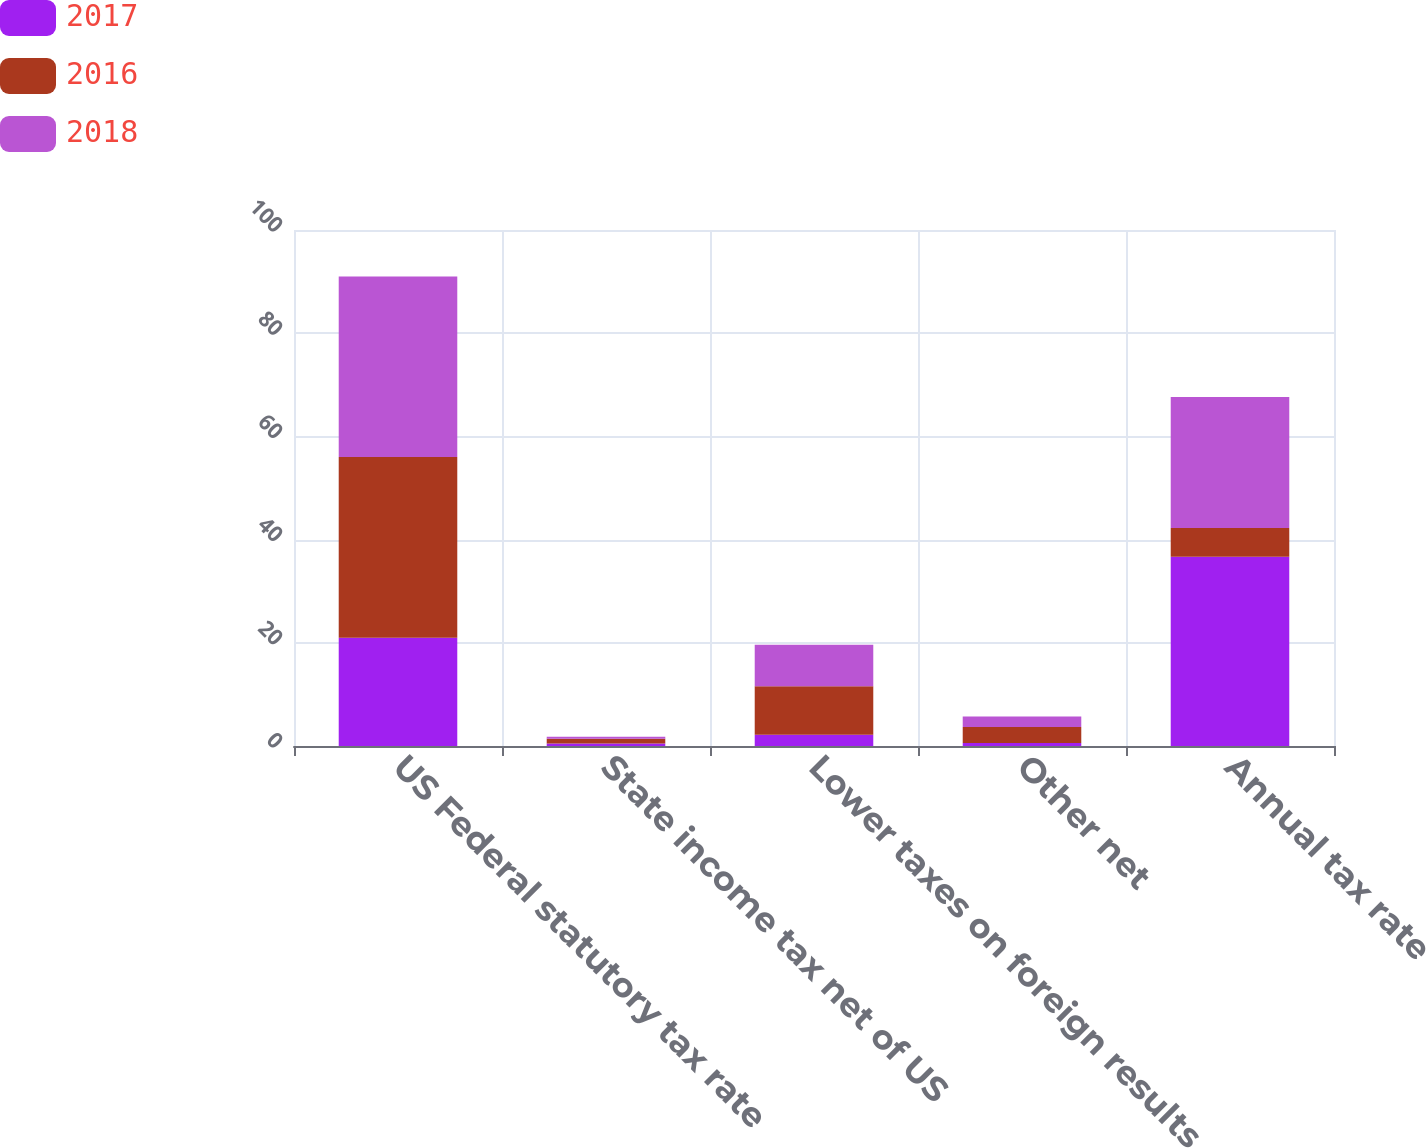<chart> <loc_0><loc_0><loc_500><loc_500><stacked_bar_chart><ecel><fcel>US Federal statutory tax rate<fcel>State income tax net of US<fcel>Lower taxes on foreign results<fcel>Other net<fcel>Annual tax rate<nl><fcel>2017<fcel>21<fcel>0.5<fcel>2.2<fcel>0.6<fcel>36.7<nl><fcel>2016<fcel>35<fcel>0.9<fcel>9.4<fcel>3.1<fcel>5.55<nl><fcel>2018<fcel>35<fcel>0.4<fcel>8<fcel>2<fcel>25.4<nl></chart> 